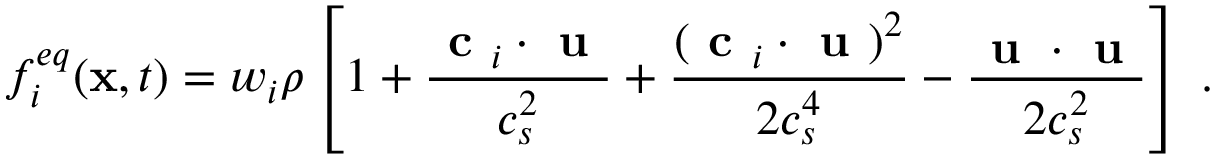<formula> <loc_0><loc_0><loc_500><loc_500>f _ { i } ^ { e q } ( x , t ) = w _ { i } \rho \left [ 1 + \frac { c _ { i } \cdot u } { c _ { s } ^ { 2 } } + \frac { ( c _ { i } \cdot u ) ^ { 2 } } { 2 c _ { s } ^ { 4 } } - \frac { u \cdot u } { 2 c _ { s } ^ { 2 } } \right ] \, .</formula> 